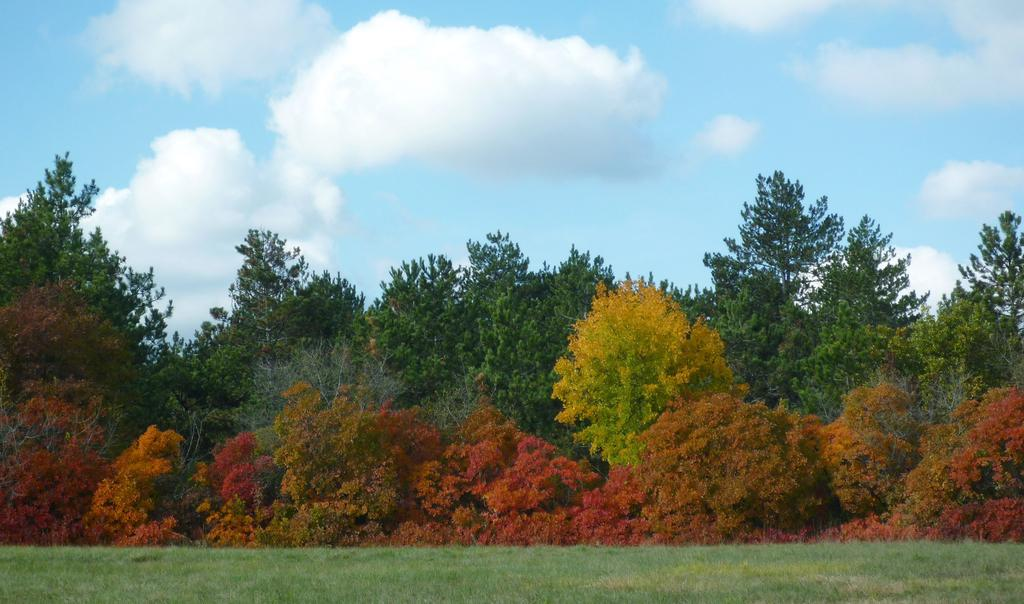What type of vegetation can be seen in the image? There is grass in the image. What other natural elements are present in the image? There are trees in the image. What is visible in the background of the image? The sky is visible in the background of the image. What can be observed in the sky? Clouds are present in the sky. What type of iron is being used to shape the clouds in the image? There is no iron present in the image, and the clouds are naturally occurring in the sky. 